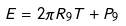<formula> <loc_0><loc_0><loc_500><loc_500>E = 2 \pi R _ { 9 } T + P _ { 9 }</formula> 